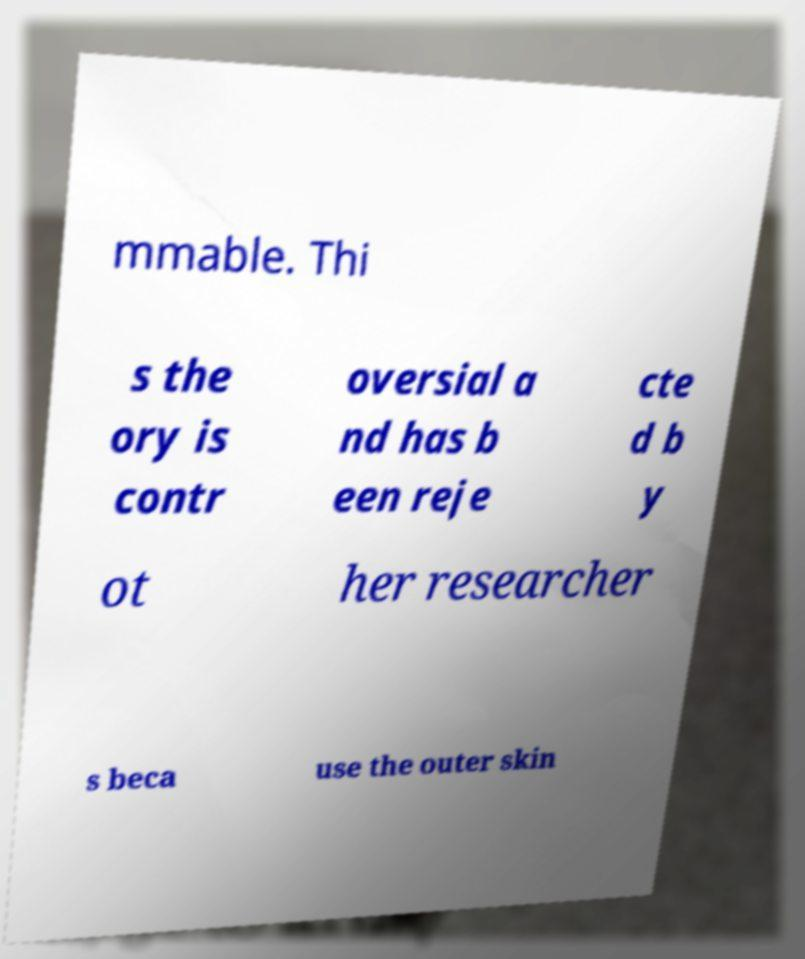Can you accurately transcribe the text from the provided image for me? mmable. Thi s the ory is contr oversial a nd has b een reje cte d b y ot her researcher s beca use the outer skin 